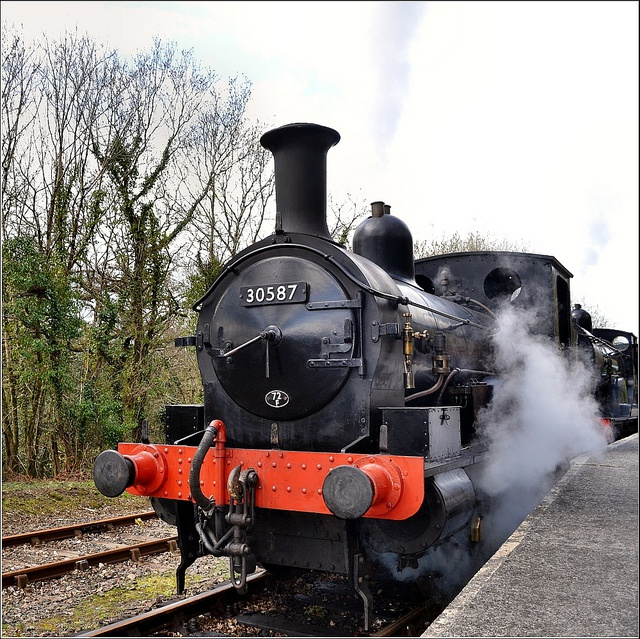Describe the objects in this image and their specific colors. I can see a train in black, gray, darkgray, and red tones in this image. 